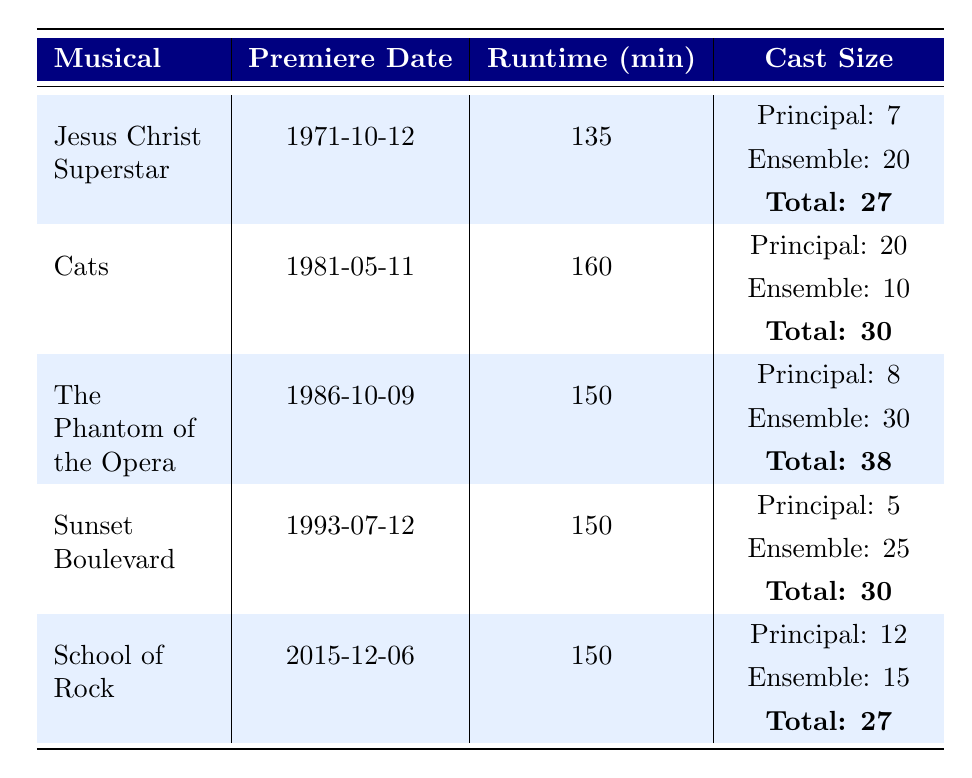What is the runtime of "Cats"? The runtime for "Cats" is listed directly in the table under the Runtime column. It shows 160 minutes.
Answer: 160 Which musical has the largest cast size? By comparing the 'Total' cast sizes listed for each musical, "The Phantom of the Opera" has the largest cast size with a total of 38.
Answer: The Phantom of the Opera How many principal roles are in "Sunset Boulevard"? The table specifies the number of principal roles for "Sunset Boulevard" under its Cast Size section, which shows there are 5 principal roles.
Answer: 5 What is the difference in runtime between "Jesus Christ Superstar" and "School of Rock"? The runtime for "Jesus Christ Superstar" is 135 minutes and for "School of Rock" it is 150 minutes. The difference is 150 - 135 = 15 minutes.
Answer: 15 Is "The Phantom of the Opera" longer than "Cats"? The runtime for "The Phantom of the Opera" is 150 minutes, while "Cats" has a runtime of 160 minutes. Since 150 is less than 160, "The Phantom of the Opera" is not longer.
Answer: No What is the average cast size of Andrew Lloyd Webber's musicals listed? The total cast sizes are: 27, 30, 38, 30, 27. Calculating the average, we add these: 27 + 30 + 38 + 30 + 27 = 152, then divide by 5 (the number of musicals): 152/5 = 30.4.
Answer: 30.4 Which musical was premiered first? By looking at the Premiere Date for each musical, "Jesus Christ Superstar" has the earliest date of 1971-10-12 compared to the others.
Answer: Jesus Christ Superstar How many more ensemble members are in "The Phantom of the Opera" compared to "School of Rock"? The ensemble in "The Phantom of the Opera" is 30 and in "School of Rock," it's 15. The difference is 30 - 15 = 15 ensemble members.
Answer: 15 What is the total cast size for all musicals combined? The total cast sizes from the table are 27, 30, 38, 30, and 27. Summing these gives 27 + 30 + 38 + 30 + 27 = 152.
Answer: 152 Is the runtime of "Jesus Christ Superstar" less than the average runtime of the musicals? The runtimes are 135 (Jesus Christ Superstar), 160 (Cats), 150 (The Phantom of the Opera), 150 (Sunset Boulevard), and 150 (School of Rock). The average is (135 + 160 + 150 + 150 + 150) / 5 = 145. Since 135 is less than 145, the statement is true.
Answer: Yes 